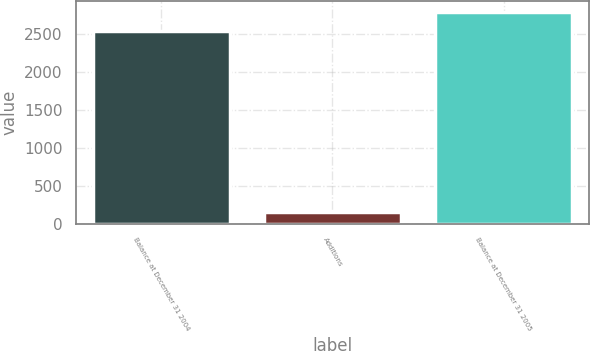<chart> <loc_0><loc_0><loc_500><loc_500><bar_chart><fcel>Balance at December 31 2004<fcel>Additions<fcel>Balance at December 31 2005<nl><fcel>2545<fcel>146<fcel>2798<nl></chart> 